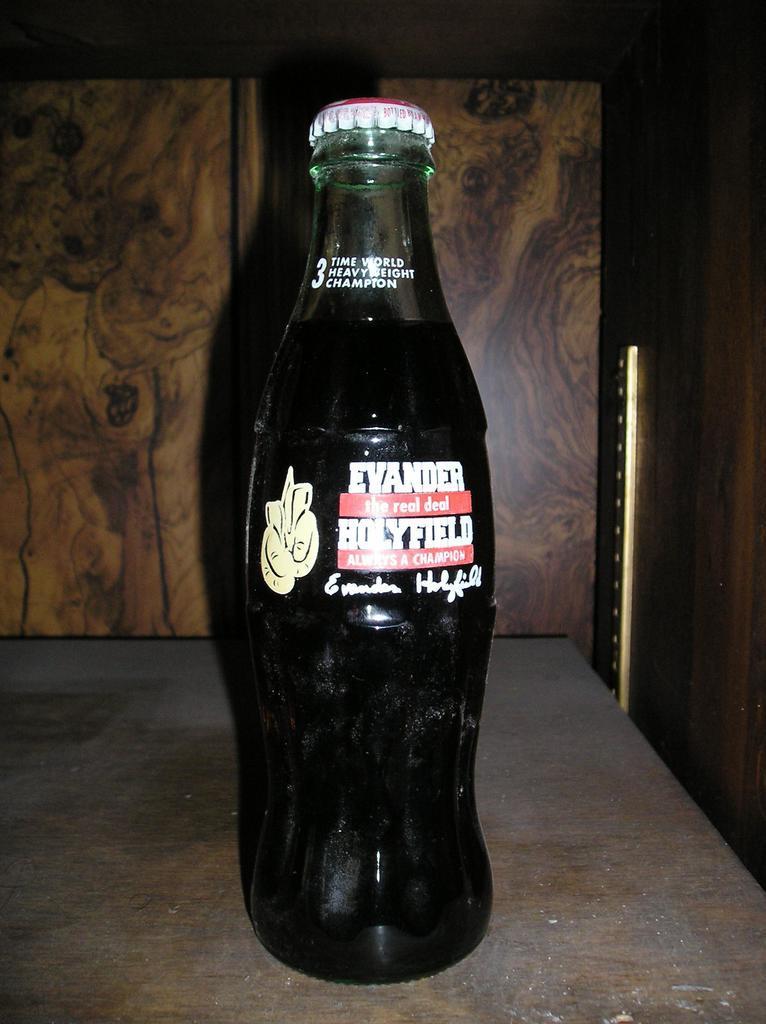Could you give a brief overview of what you see in this image? There is a room. The bottle on a table. The bottle has a sticker. The bottle has a cap. We can see in the background there is a cupboard. 